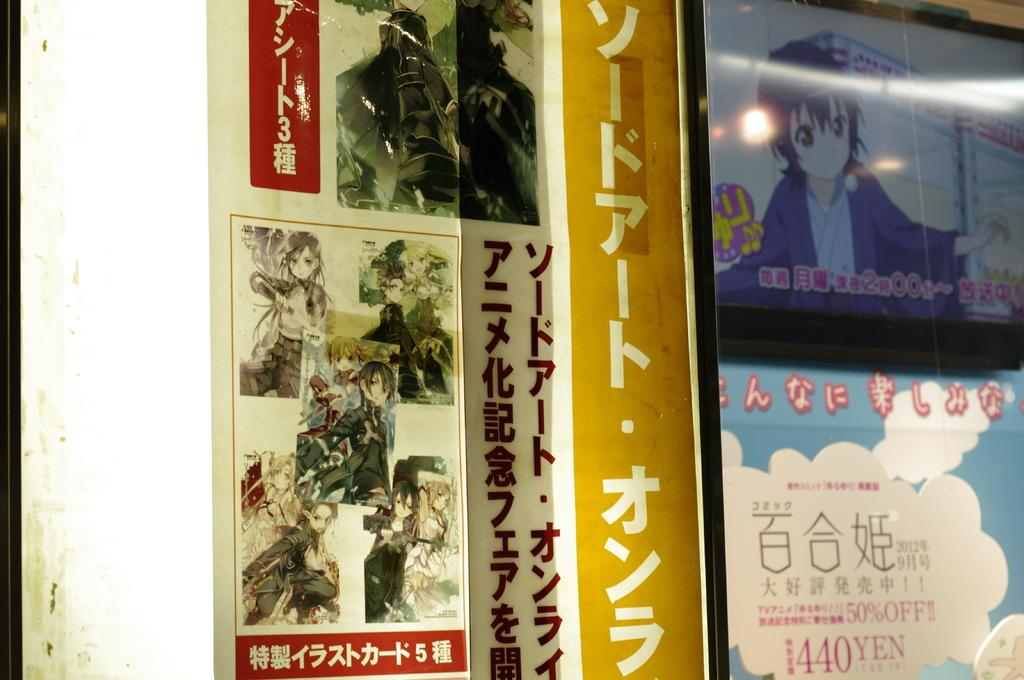Provide a one-sentence caption for the provided image. Several posters of Japanese Manga art, one is marked 440 Yen. 